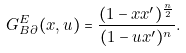<formula> <loc_0><loc_0><loc_500><loc_500>G ^ { E } _ { B \partial } ( x , u ) = \frac { ( 1 - x x ^ { \prime } ) ^ { \frac { n } { 2 } } } { ( 1 - u x ^ { \prime } ) ^ { n } } .</formula> 